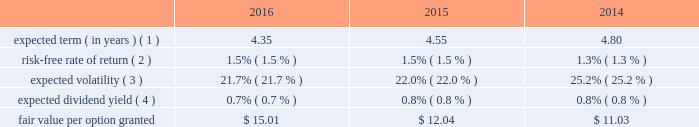Visa inc .
Notes to consolidated financial statements 2014 ( continued ) september 30 , 2016 note 16 2014share-based compensation 2007 equity incentive compensation plan the company 2019s 2007 equity incentive compensation plan , or the eip , authorizes the compensation committee of the board of directors to grant non-qualified stock options ( 201coptions 201d ) , restricted stock awards ( 201crsas 201d ) , restricted stock units ( 201crsus 201d ) and performance-based shares to its employees and non-employee directors , for up to 236 million shares of class a common stock .
Shares available for award may be either authorized and unissued or previously issued shares subsequently acquired by the company .
The eip will continue to be in effect until all of the common stock available under the eip is delivered and all restrictions on those shares have lapsed , unless the eip is terminated earlier by the company 2019s board of directors .
In january 2016 , the company 2019s board of directors approved an amendment of the eip effective february 3 , 2016 , such that awards may be granted under the plan until january 31 , 2022 .
Share-based compensation cost is recorded net of estimated forfeitures on a straight-line basis for awards with service conditions only , and on a graded-vesting basis for awards with service , performance and market conditions .
The company 2019s estimated forfeiture rate is based on an evaluation of historical , actual and trended forfeiture data .
For fiscal 2016 , 2015 and 2014 , the company recorded share-based compensation cost related to the eip of $ 211 million , $ 184 million and $ 172 million , respectively , in personnel on its consolidated statements of operations .
The related tax benefits were $ 62 million , $ 54 million and $ 51 million for fiscal 2016 , 2015 and 2014 , respectively .
The amount of capitalized share-based compensation cost was immaterial during fiscal 2016 , 2015 and all per share amounts and number of shares outstanding presented below reflect the four-for-one stock split that was effected in the second quarter of fiscal 2015 .
See note 14 2014stockholders 2019 equity .
Options options issued under the eip expire 10 years from the date of grant and primarily vest ratably over 3 years from the date of grant , subject to earlier vesting in full under certain conditions .
During fiscal 2016 , 2015 and 2014 , the fair value of each stock option was estimated on the date of grant using a black-scholes option pricing model with the following weighted-average assumptions: .
( 1 ) this assumption is based on the company 2019s historical option exercises and those of a set of peer companies that management believes is generally comparable to visa .
The company 2019s data is weighted based on the number of years between the measurement date and visa 2019s initial public offering as a percentage of the options 2019 contractual term .
The relative weighting placed on visa 2019s data and peer data in fiscal 2016 was approximately 77% ( 77 % ) and 23% ( 23 % ) , respectively , 67% ( 67 % ) and 33% ( 33 % ) in fiscal 2015 , respectively , and 58% ( 58 % ) and 42% ( 42 % ) in fiscal 2014 , respectively. .
What was the ratio of the share based compensation to the related tax benefits in 2016? 
Computations: (211 / 62)
Answer: 3.40323. 